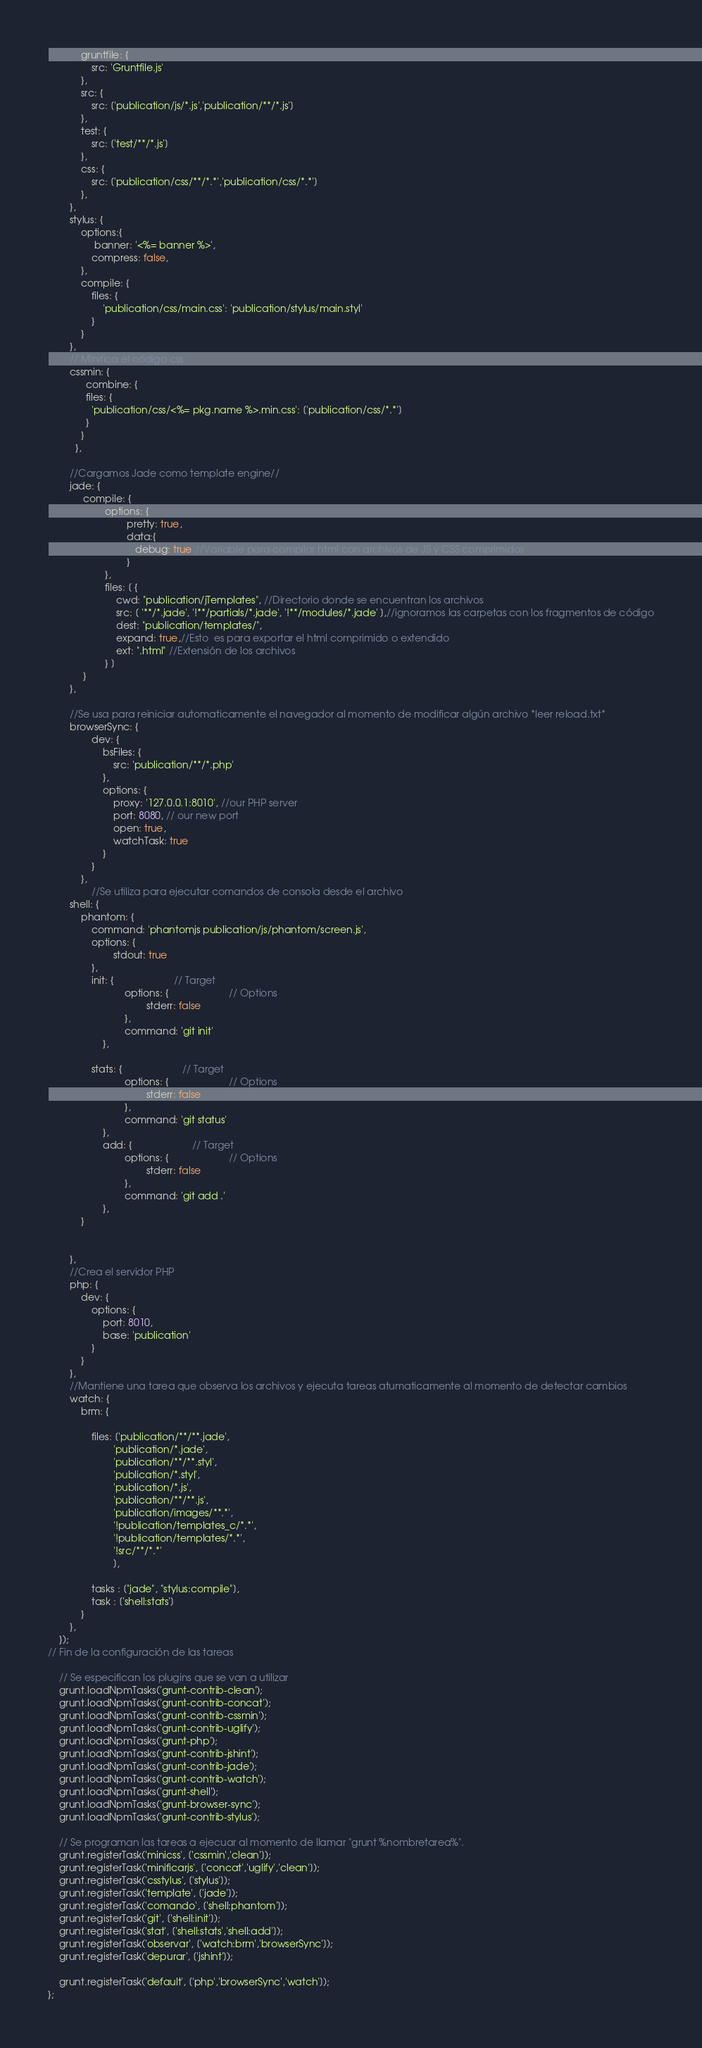Convert code to text. <code><loc_0><loc_0><loc_500><loc_500><_JavaScript_>			gruntfile: {
				src: 'Gruntfile.js'
			},
			src: {
				src: ['publication/js/*.js','publication/**/*.js']
			},
			test: {
				src: ['test/**/*.js']
			},
			css: {
				src: ['publication/css/**/*.*','publication/css/*.*']
			},
		},
		stylus: {
			options:{
				 banner: '<%= banner %>', 
				compress: false,
			},
			compile: {
				files: {
					'publication/css/main.css': 'publication/stylus/main.styl'
				}
			}
		},
		// Minifica el código css
		cssmin: {
		      combine: {
		      files: {
		        'publication/css/<%= pkg.name %>.min.css': ['publication/css/*.*']
		      }
		    }
		  },
		
		//Cargamos Jade como template engine//
		jade: {
			 compile: {
					 options: {
							 pretty: true,
							 data:{
							 	debug: true //Variable para compilar html con archivos de JS y CSS comprimidos 
							 }
					 },
					 files: [ {
						 cwd: "publication/jTemplates", //Directorio donde se encuentran los archivos
						 src: [ '**/*.jade', '!**/partials/*.jade', '!**/modules/*.jade' ],//ignoramos las carpetas con los fragmentos de código
						 dest: "publication/templates/",
						 expand: true,//Esto  es para exportar el html comprimido o extendido
						 ext: ".html" //Extensión de los archivos
					 } ]
			 }
		},

		//Se usa para reiniciar automaticamente el navegador al momento de modificar algún archivo *leer reload.txt*
		browserSync: {
				dev: {
					bsFiles: {
						src: 'publication/**/*.php'
					},
					options: {
						proxy: '127.0.0.1:8010', //our PHP server
						port: 8080, // our new port
						open: true,
						watchTask: true
					}
				}
			},
				//Se utiliza para ejecutar comandos de consola desde el archivo
		shell: {
			phantom: {
				command: 'phantomjs publication/js/phantom/screen.js',
				options: {
						stdout: true
				},
				init: {                      // Target
							options: {                      // Options
									stderr: false
							},
							command: 'git init'
					},

				stats: {                      // Target
							options: {                      // Options
									stderr: false
							},
							command: 'git status'
					},
					add: {                      // Target
							options: {                      // Options
									stderr: false
							},
							command: 'git add .'
					},
			}
	
	
		},
		//Crea el servidor PHP
		php: {
            dev: {
                options: {
                    port: 8010,
                    base: 'publication'
                }
            }
        },
		//Mantiene una tarea que observa los archivos y ejecuta tareas atumaticamente al momento de detectar cambios
		watch: {
			brm: {
				
				files: ['publication/**/**.jade',
						'publication/*.jade',
						'publication/**/**.styl',
						'publication/*.styl',
						'publication/*.js',
						'publication/**/**.js',
						'publication/images/**.*',
						'!publication/templates_c/*.*',
						'!publication/templates/*.*',
						'!src/**/*.*'
						],

				tasks : ["jade", "stylus:compile"],
				task : ['shell:stats']
			}
		},
	});
// Fin de la configuración de las tareas

	// Se especifican los plugins que se van a utilizar
	grunt.loadNpmTasks('grunt-contrib-clean');
	grunt.loadNpmTasks('grunt-contrib-concat');
	grunt.loadNpmTasks('grunt-contrib-cssmin');
	grunt.loadNpmTasks('grunt-contrib-uglify');
	grunt.loadNpmTasks('grunt-php');
	grunt.loadNpmTasks('grunt-contrib-jshint');
	grunt.loadNpmTasks('grunt-contrib-jade');
	grunt.loadNpmTasks('grunt-contrib-watch');
	grunt.loadNpmTasks('grunt-shell');
	grunt.loadNpmTasks('grunt-browser-sync');
	grunt.loadNpmTasks('grunt-contrib-stylus');

	// Se programan las tareas a ejecuar al momento de llamar "grunt %nombretarea%".
	grunt.registerTask('minicss', ['cssmin','clean']);
	grunt.registerTask('minificarjs', ['concat','uglify','clean']);
	grunt.registerTask('csstylus', ['stylus']);
	grunt.registerTask('template', ['jade']);
	grunt.registerTask('comando', ['shell:phantom']);
	grunt.registerTask('git', ['shell:init']);
	grunt.registerTask('stat', ['shell:stats','shell:add']);
	grunt.registerTask('observar', ['watch:brm','browserSync']);
	grunt.registerTask('depurar', ['jshint']);

	grunt.registerTask('default', ['php','browserSync','watch']); 
};</code> 